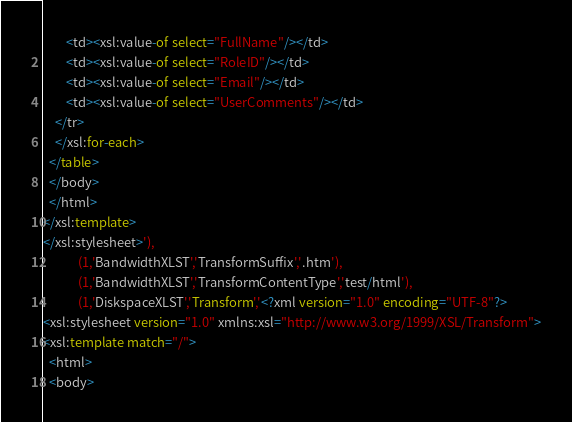<code> <loc_0><loc_0><loc_500><loc_500><_SQL_>        <td><xsl:value-of select="FullName"/></td>
        <td><xsl:value-of select="RoleID"/></td>
        <td><xsl:value-of select="Email"/></td>
        <td><xsl:value-of select="UserComments"/></td>
    </tr>
    </xsl:for-each>
  </table>
  </body>
  </html>
</xsl:template>
</xsl:stylesheet>'),
			(1,'BandwidthXLST','TransformSuffix','.htm'),
			(1,'BandwidthXLST','TransformContentType','test/html'),
			(1,'DiskspaceXLST','Transform','<?xml version="1.0" encoding="UTF-8"?>
<xsl:stylesheet version="1.0" xmlns:xsl="http://www.w3.org/1999/XSL/Transform">
<xsl:template match="/">
  <html>
  <body></code> 